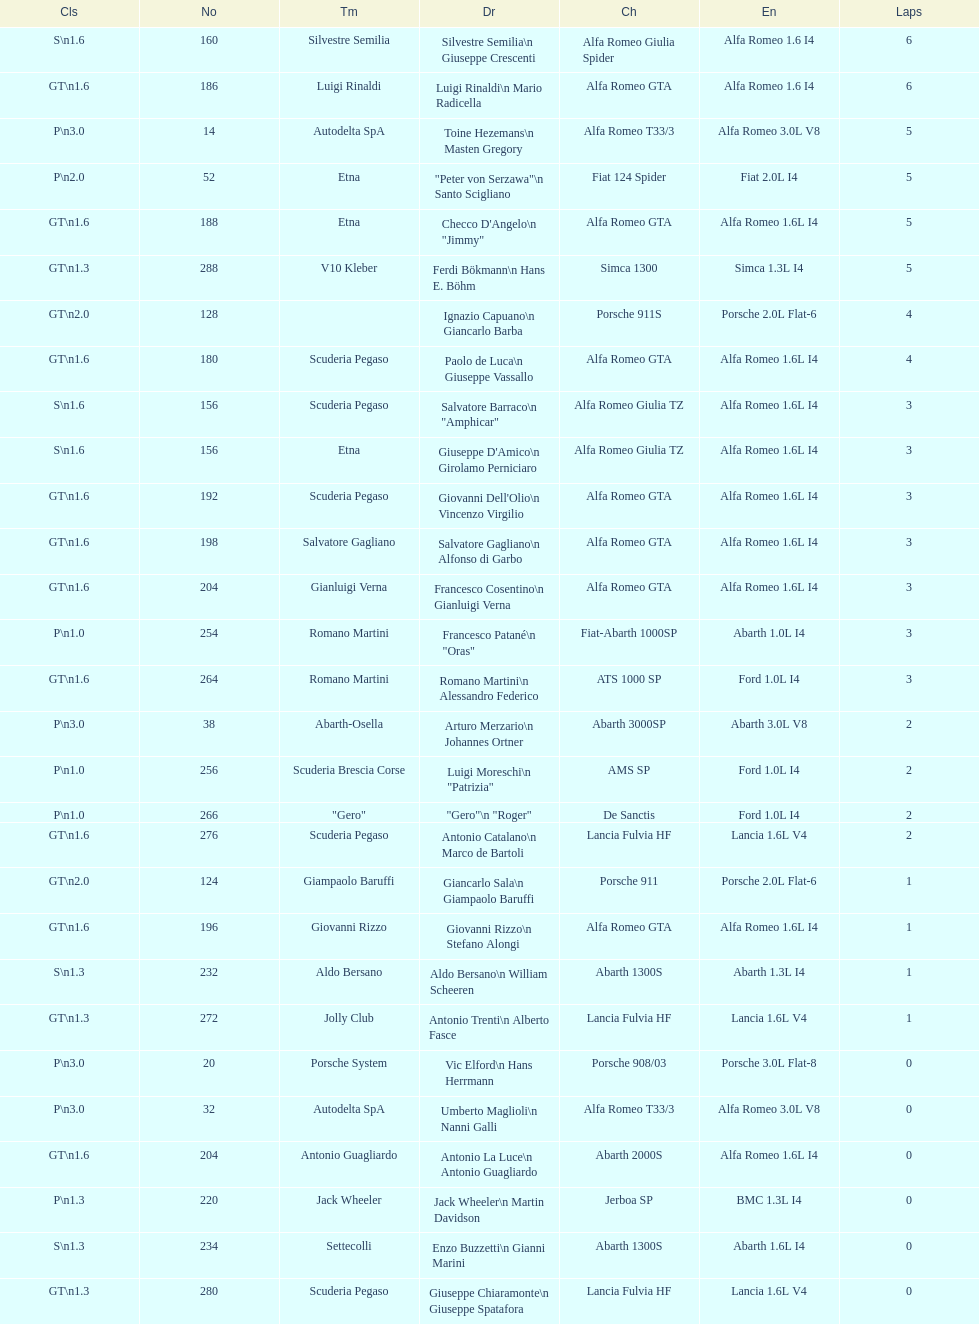How many drivers are from italy? 48. Would you mind parsing the complete table? {'header': ['Cls', 'No', 'Tm', 'Dr', 'Ch', 'En', 'Laps'], 'rows': [['S\\n1.6', '160', 'Silvestre Semilia', 'Silvestre Semilia\\n Giuseppe Crescenti', 'Alfa Romeo Giulia Spider', 'Alfa Romeo 1.6 I4', '6'], ['GT\\n1.6', '186', 'Luigi Rinaldi', 'Luigi Rinaldi\\n Mario Radicella', 'Alfa Romeo GTA', 'Alfa Romeo 1.6 I4', '6'], ['P\\n3.0', '14', 'Autodelta SpA', 'Toine Hezemans\\n Masten Gregory', 'Alfa Romeo T33/3', 'Alfa Romeo 3.0L V8', '5'], ['P\\n2.0', '52', 'Etna', '"Peter von Serzawa"\\n Santo Scigliano', 'Fiat 124 Spider', 'Fiat 2.0L I4', '5'], ['GT\\n1.6', '188', 'Etna', 'Checco D\'Angelo\\n "Jimmy"', 'Alfa Romeo GTA', 'Alfa Romeo 1.6L I4', '5'], ['GT\\n1.3', '288', 'V10 Kleber', 'Ferdi Bökmann\\n Hans E. Böhm', 'Simca 1300', 'Simca 1.3L I4', '5'], ['GT\\n2.0', '128', '', 'Ignazio Capuano\\n Giancarlo Barba', 'Porsche 911S', 'Porsche 2.0L Flat-6', '4'], ['GT\\n1.6', '180', 'Scuderia Pegaso', 'Paolo de Luca\\n Giuseppe Vassallo', 'Alfa Romeo GTA', 'Alfa Romeo 1.6L I4', '4'], ['S\\n1.6', '156', 'Scuderia Pegaso', 'Salvatore Barraco\\n "Amphicar"', 'Alfa Romeo Giulia TZ', 'Alfa Romeo 1.6L I4', '3'], ['S\\n1.6', '156', 'Etna', "Giuseppe D'Amico\\n Girolamo Perniciaro", 'Alfa Romeo Giulia TZ', 'Alfa Romeo 1.6L I4', '3'], ['GT\\n1.6', '192', 'Scuderia Pegaso', "Giovanni Dell'Olio\\n Vincenzo Virgilio", 'Alfa Romeo GTA', 'Alfa Romeo 1.6L I4', '3'], ['GT\\n1.6', '198', 'Salvatore Gagliano', 'Salvatore Gagliano\\n Alfonso di Garbo', 'Alfa Romeo GTA', 'Alfa Romeo 1.6L I4', '3'], ['GT\\n1.6', '204', 'Gianluigi Verna', 'Francesco Cosentino\\n Gianluigi Verna', 'Alfa Romeo GTA', 'Alfa Romeo 1.6L I4', '3'], ['P\\n1.0', '254', 'Romano Martini', 'Francesco Patané\\n "Oras"', 'Fiat-Abarth 1000SP', 'Abarth 1.0L I4', '3'], ['GT\\n1.6', '264', 'Romano Martini', 'Romano Martini\\n Alessandro Federico', 'ATS 1000 SP', 'Ford 1.0L I4', '3'], ['P\\n3.0', '38', 'Abarth-Osella', 'Arturo Merzario\\n Johannes Ortner', 'Abarth 3000SP', 'Abarth 3.0L V8', '2'], ['P\\n1.0', '256', 'Scuderia Brescia Corse', 'Luigi Moreschi\\n "Patrizia"', 'AMS SP', 'Ford 1.0L I4', '2'], ['P\\n1.0', '266', '"Gero"', '"Gero"\\n "Roger"', 'De Sanctis', 'Ford 1.0L I4', '2'], ['GT\\n1.6', '276', 'Scuderia Pegaso', 'Antonio Catalano\\n Marco de Bartoli', 'Lancia Fulvia HF', 'Lancia 1.6L V4', '2'], ['GT\\n2.0', '124', 'Giampaolo Baruffi', 'Giancarlo Sala\\n Giampaolo Baruffi', 'Porsche 911', 'Porsche 2.0L Flat-6', '1'], ['GT\\n1.6', '196', 'Giovanni Rizzo', 'Giovanni Rizzo\\n Stefano Alongi', 'Alfa Romeo GTA', 'Alfa Romeo 1.6L I4', '1'], ['S\\n1.3', '232', 'Aldo Bersano', 'Aldo Bersano\\n William Scheeren', 'Abarth 1300S', 'Abarth 1.3L I4', '1'], ['GT\\n1.3', '272', 'Jolly Club', 'Antonio Trenti\\n Alberto Fasce', 'Lancia Fulvia HF', 'Lancia 1.6L V4', '1'], ['P\\n3.0', '20', 'Porsche System', 'Vic Elford\\n Hans Herrmann', 'Porsche 908/03', 'Porsche 3.0L Flat-8', '0'], ['P\\n3.0', '32', 'Autodelta SpA', 'Umberto Maglioli\\n Nanni Galli', 'Alfa Romeo T33/3', 'Alfa Romeo 3.0L V8', '0'], ['GT\\n1.6', '204', 'Antonio Guagliardo', 'Antonio La Luce\\n Antonio Guagliardo', 'Abarth 2000S', 'Alfa Romeo 1.6L I4', '0'], ['P\\n1.3', '220', 'Jack Wheeler', 'Jack Wheeler\\n Martin Davidson', 'Jerboa SP', 'BMC 1.3L I4', '0'], ['S\\n1.3', '234', 'Settecolli', 'Enzo Buzzetti\\n Gianni Marini', 'Abarth 1300S', 'Abarth 1.6L I4', '0'], ['GT\\n1.3', '280', 'Scuderia Pegaso', 'Giuseppe Chiaramonte\\n Giuseppe Spatafora', 'Lancia Fulvia HF', 'Lancia 1.6L V4', '0']]} 